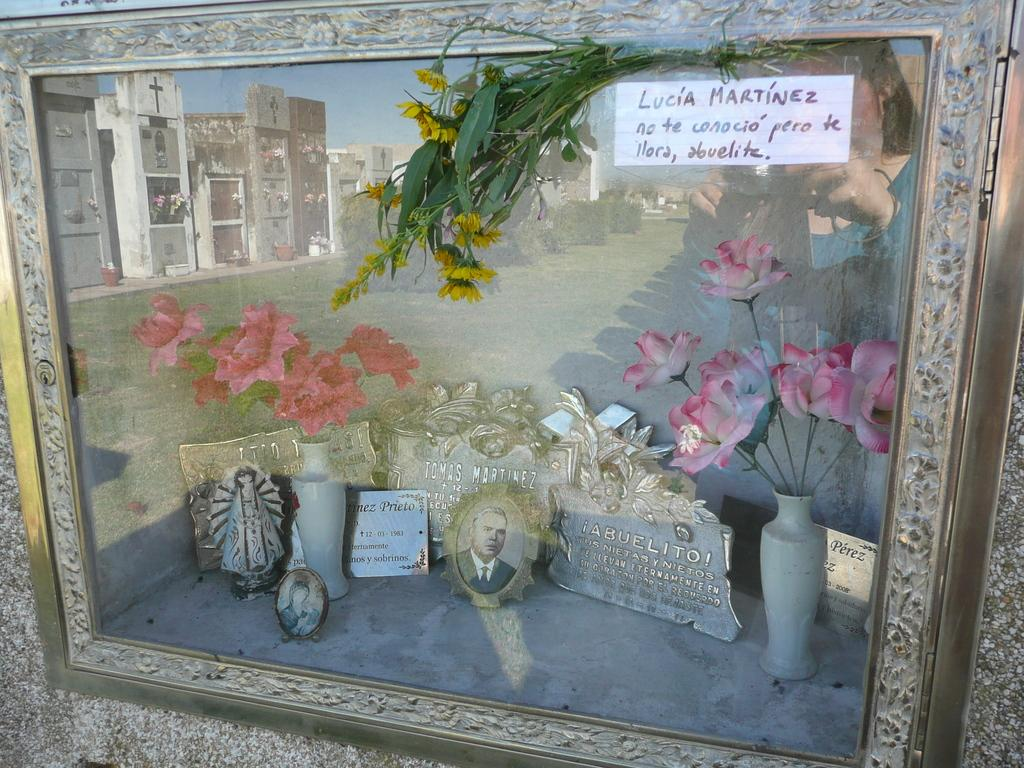What object in the image contains flower pots and pictures? The photo frame in the image contains flower pots and pictures. What type of vegetation is visible in the image? There is grass visible in the image. What type of structures can be seen in the image? There are buildings visible in the image. What part of the natural environment is visible in the image? The sky is visible in the image. Where is the person located in the image? The person is on the right side of the image. What is the person holding in the image? The person is holding a camera. How many frogs can be seen jumping in the image? There are no frogs visible in the image. What type of division is being performed by the person in the image? The person in the image is not performing any division; they are holding a camera. 